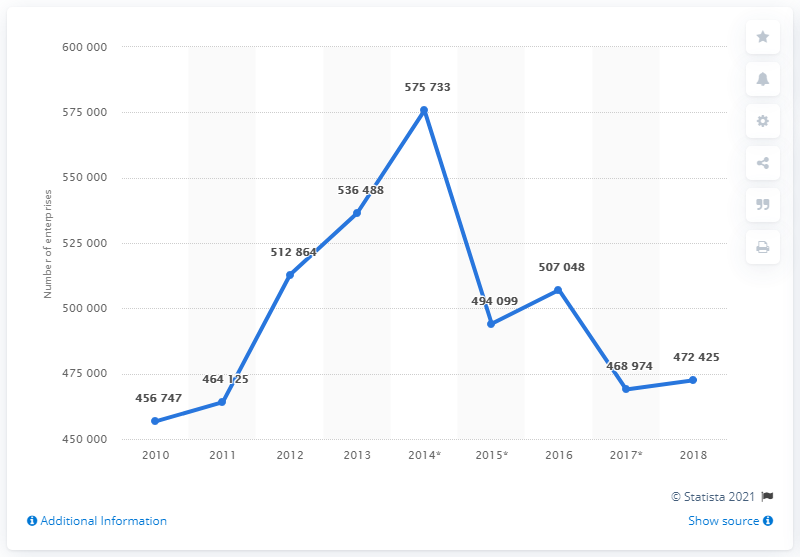Identify some key points in this picture. In 2017, there were 472,425 construction companies in France. 